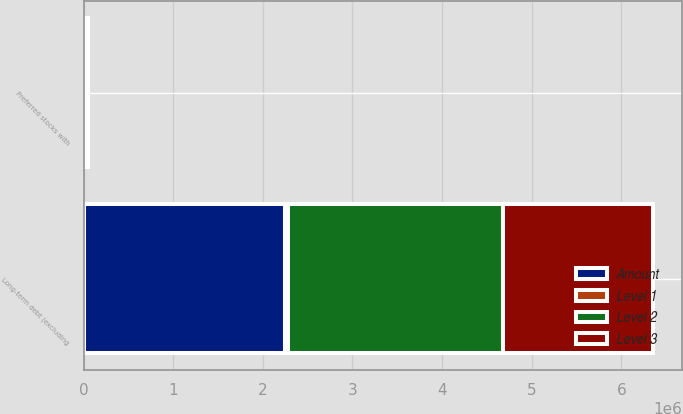Convert chart. <chart><loc_0><loc_0><loc_500><loc_500><stacked_bar_chart><ecel><fcel>Preferred stocks with<fcel>Long-term debt (excluding<nl><fcel>Level 1<fcel>20511<fcel>27263<nl><fcel>Level 2<fcel>0<fcel>2.40085e+06<nl><fcel>Level 3<fcel>0<fcel>1.67778e+06<nl><fcel>Amount<fcel>27263<fcel>2.25227e+06<nl></chart> 